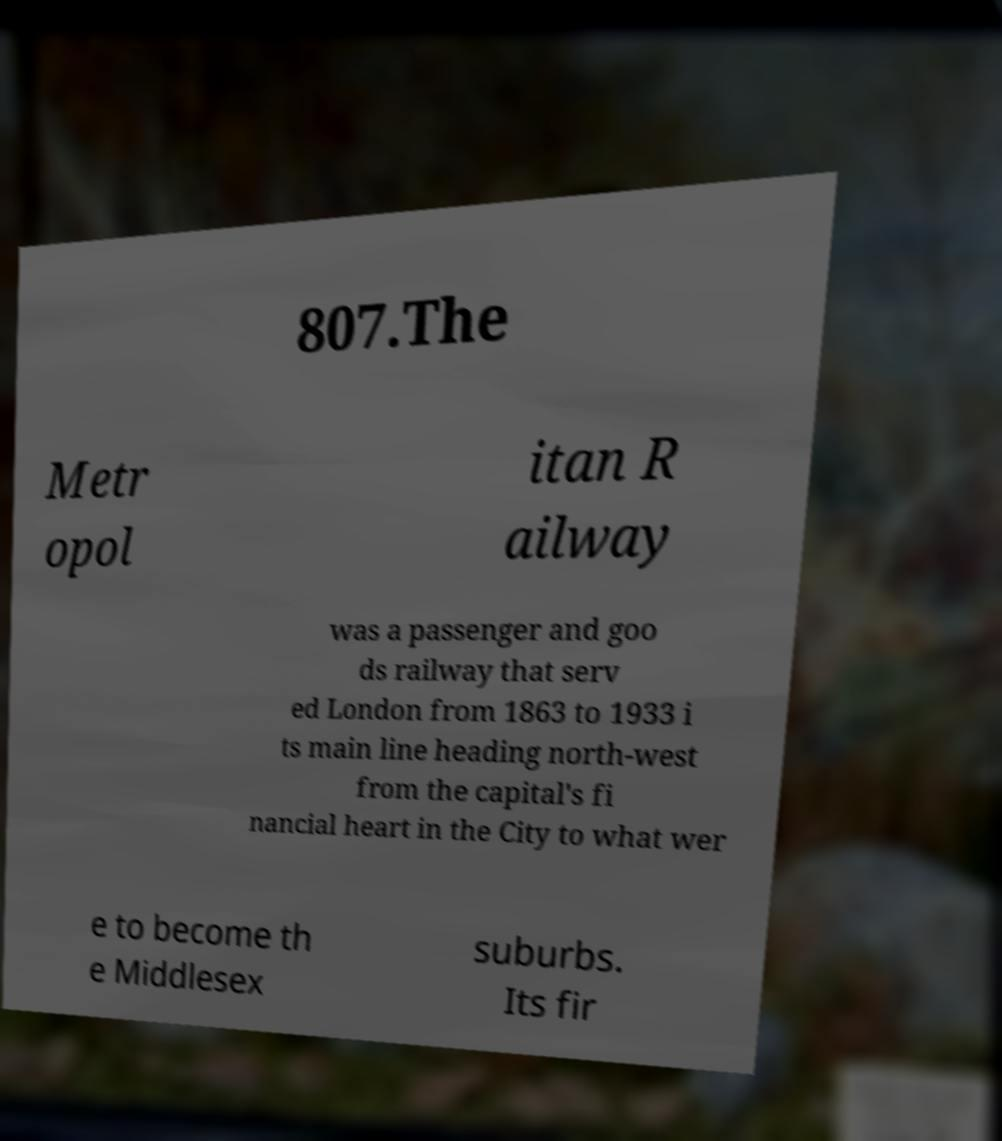For documentation purposes, I need the text within this image transcribed. Could you provide that? 807.The Metr opol itan R ailway was a passenger and goo ds railway that serv ed London from 1863 to 1933 i ts main line heading north-west from the capital's fi nancial heart in the City to what wer e to become th e Middlesex suburbs. Its fir 